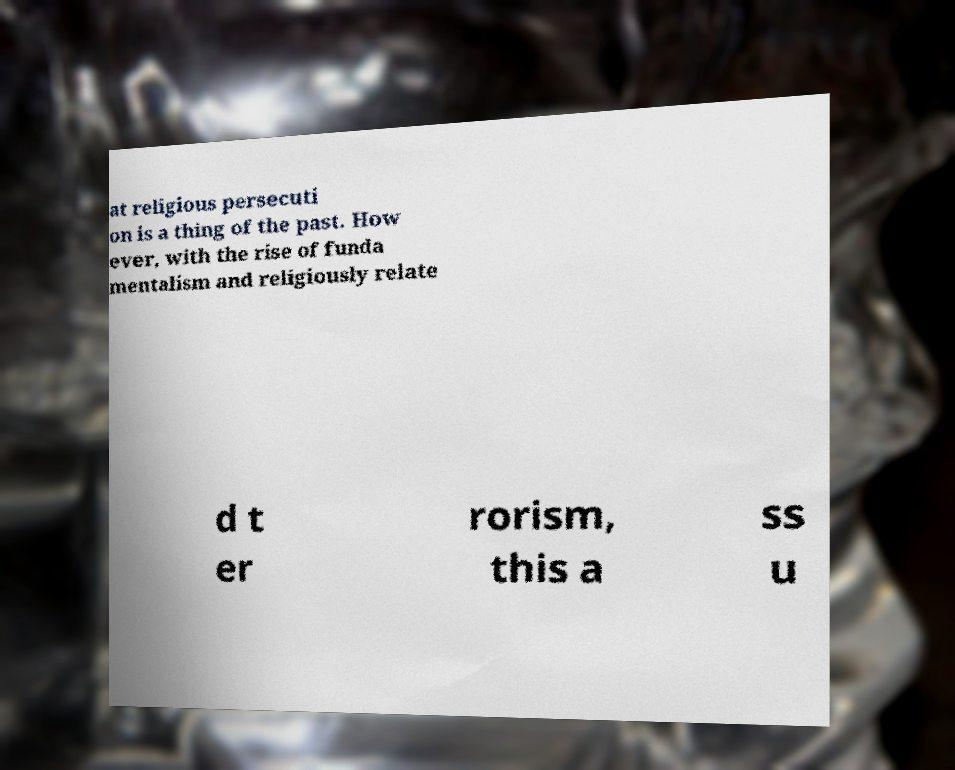For documentation purposes, I need the text within this image transcribed. Could you provide that? at religious persecuti on is a thing of the past. How ever, with the rise of funda mentalism and religiously relate d t er rorism, this a ss u 